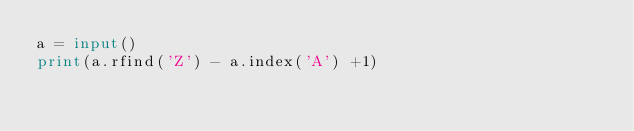<code> <loc_0><loc_0><loc_500><loc_500><_Python_>a = input()
print(a.rfind('Z') - a.index('A') +1)</code> 